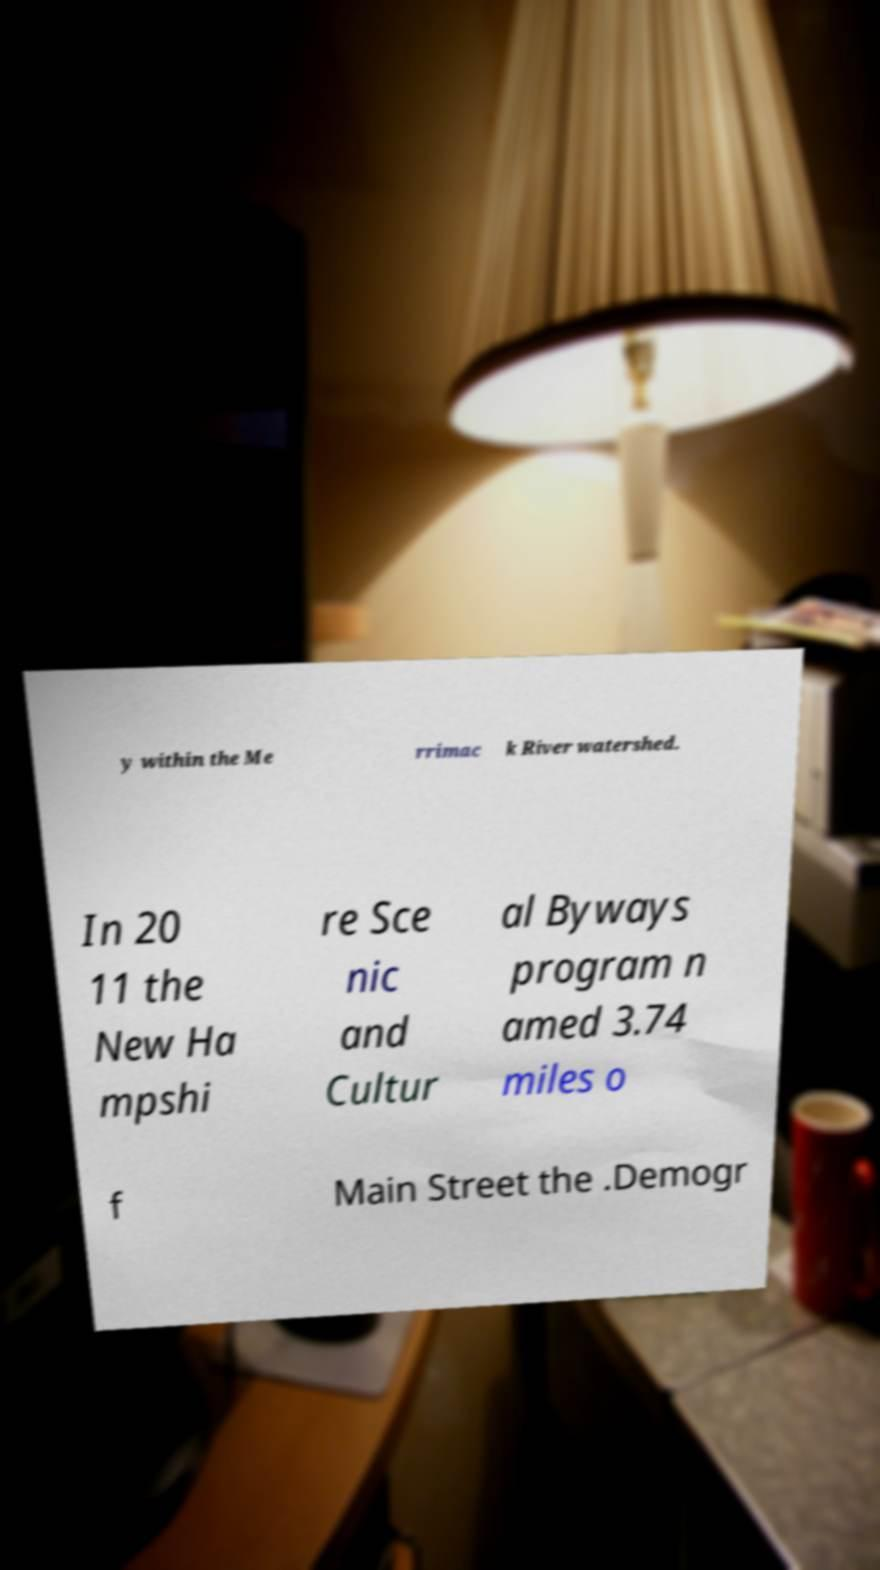For documentation purposes, I need the text within this image transcribed. Could you provide that? y within the Me rrimac k River watershed. In 20 11 the New Ha mpshi re Sce nic and Cultur al Byways program n amed 3.74 miles o f Main Street the .Demogr 